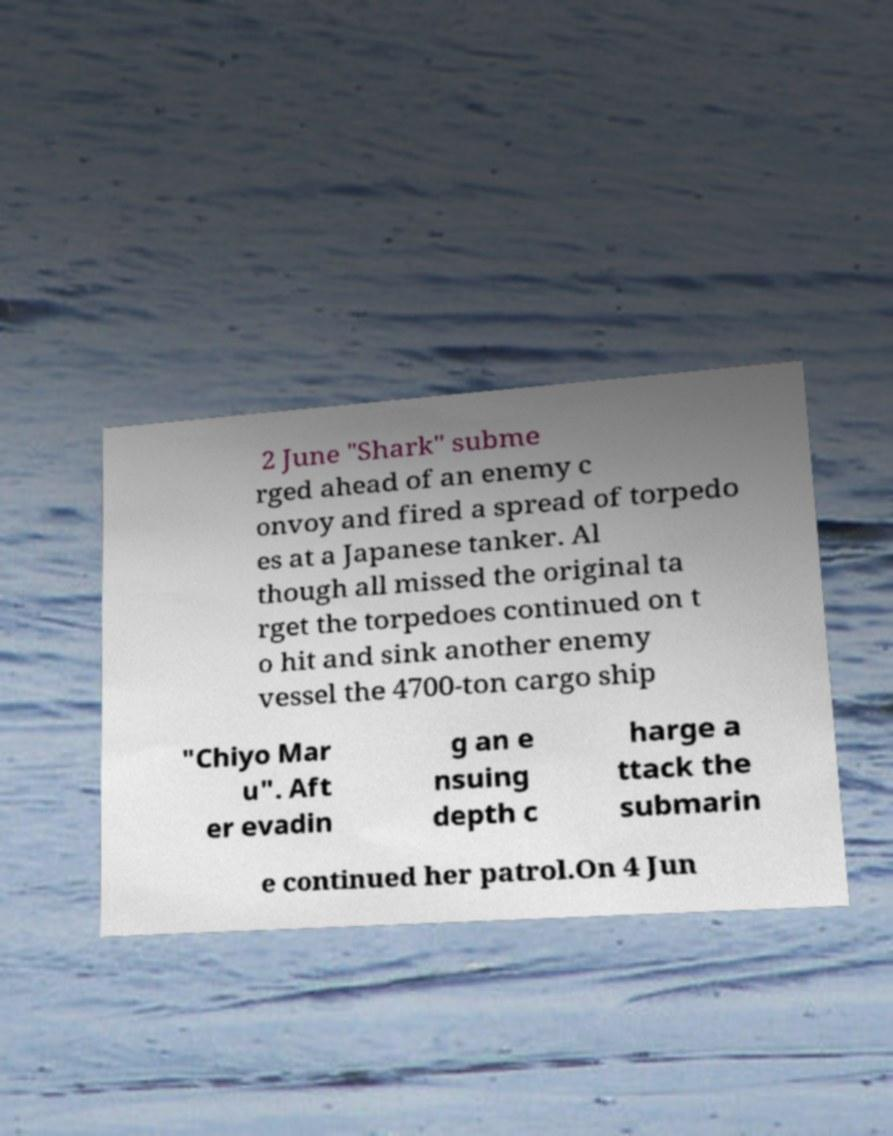What messages or text are displayed in this image? I need them in a readable, typed format. 2 June "Shark" subme rged ahead of an enemy c onvoy and fired a spread of torpedo es at a Japanese tanker. Al though all missed the original ta rget the torpedoes continued on t o hit and sink another enemy vessel the 4700-ton cargo ship "Chiyo Mar u". Aft er evadin g an e nsuing depth c harge a ttack the submarin e continued her patrol.On 4 Jun 